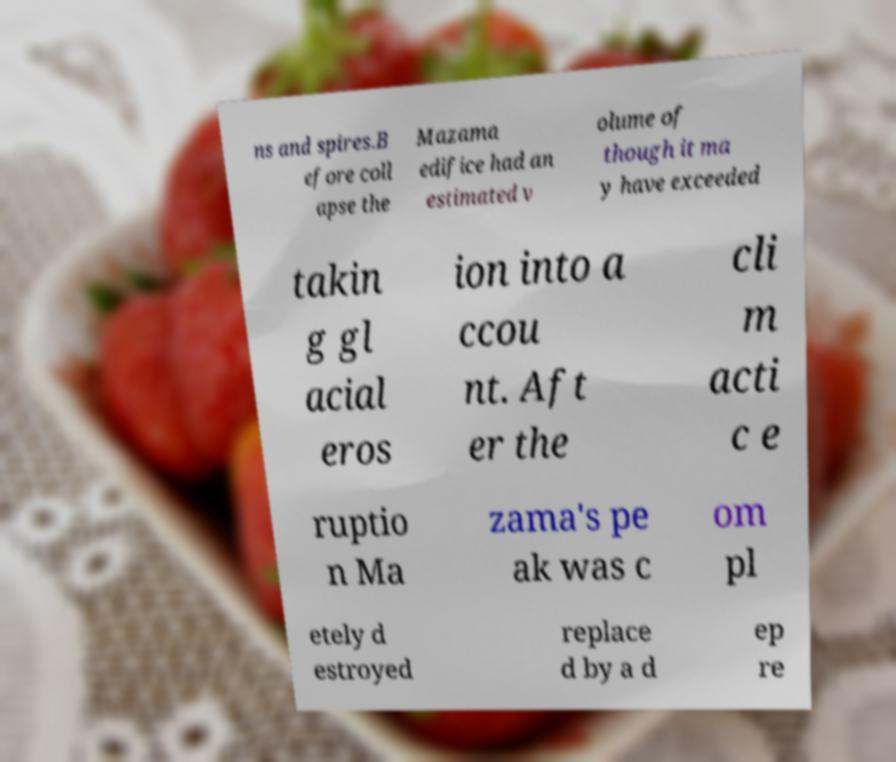I need the written content from this picture converted into text. Can you do that? ns and spires.B efore coll apse the Mazama edifice had an estimated v olume of though it ma y have exceeded takin g gl acial eros ion into a ccou nt. Aft er the cli m acti c e ruptio n Ma zama's pe ak was c om pl etely d estroyed replace d by a d ep re 